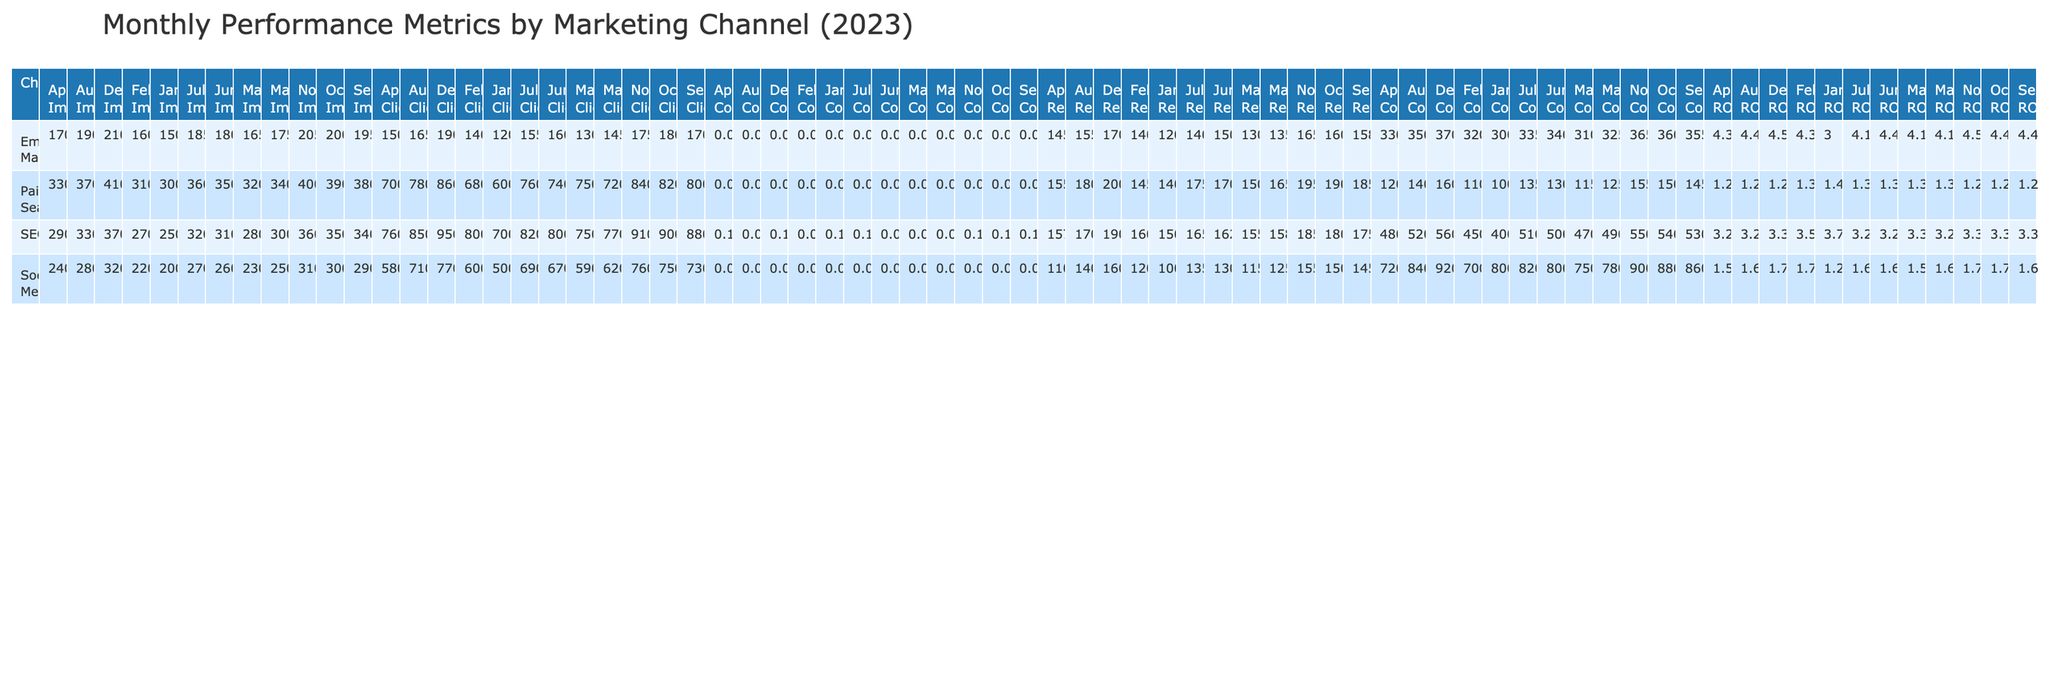What was the total revenue generated from Email Marketing in March? In March, the revenue for Email Marketing is listed as 13000. There are no additional revenue amounts to consider for that month.
Answer: 13000 What was the conversion rate for SEO in June? The table specifies the conversion rate for SEO in June, which shows a value of 0.09.
Answer: 0.09 Which marketing channel had the highest ROI in February? In February, the ROIs for the channels are: Email Marketing (4.38), Social Media (1.71), SEO (3.55), and Paid Search (1.32). Email Marketing has the highest ROI at 4.38.
Answer: Email Marketing What is the average number of clicks across all channels for the month of July? The number of clicks in July are as follows: Email Marketing (1550), Social Media (6900), SEO (8200), and Paid Search (7600). Summing these gives 1550 + 6900 + 8200 + 7600 = 24250. Dividing by 4 channels gives an average of 24250 / 4 = 6062.5.
Answer: 6062.5 Is the revenue from Paid Search higher than that from Social Media in November? In November, Paid Search generated 19500 in revenue while Social Media generated 15500. Since 19500 is greater than 15500, the revenue from Paid Search is indeed higher.
Answer: Yes What was the difference in impressions between SEO and Paid Search in October? The impressions for SEO in October are 350000, while for Paid Search they are 390000. The difference is calculated as 390000 - 350000 = 40000.
Answer: 40000 Which month saw the highest total impressions from all channels combined? To find this, sum the impressions for all channels in each month. The highest sum is in December, where the totals are: 210000 (Email) + 320000 (Social) + 370000 (SEO) + 410000 (Paid) = 1310000.
Answer: December What pattern can be observed with SEO's conversion rates throughout the year? The conversion rates for SEO month-by-month are 0.10 (Jan), 0.09 (Feb), 0.09 (Mar), 0.10 (Apr), 0.09 (May), 0.09 (Jun), 0.10 (Jul), 0.09 (Aug), 0.10 (Sep), 0.10 (Oct), 0.10 (Nov), and 0.10 (Dec). This data shows that the conversion rate consistently remains between 0.09 and 0.10, indicating stability.
Answer: SEO's conversion rates are stable around 0.09-0.10 Which marketing channel had the most consistent ROI throughout the year? Reviewing the ROI for each channel by month reveals the following: Email Marketing ranges from 3.00 to 4.59, Social Media from 1.25 to 1.74, SEO from 3.27 to 3.75, and Paid Search from 1.26 to 1.40. Email Marketing exhibits the highest range but remains considerably stable at higher values than others.
Answer: Email Marketing Did any marketing channel generate more than 20000 in revenue in December? In December, the revenues are: Email Marketing (17000), Social Media (16000), SEO (19000), and Paid Search (20000). None surpassed 20000, as the maximum revenue listed is exactly 20000 from Paid Search.
Answer: No 